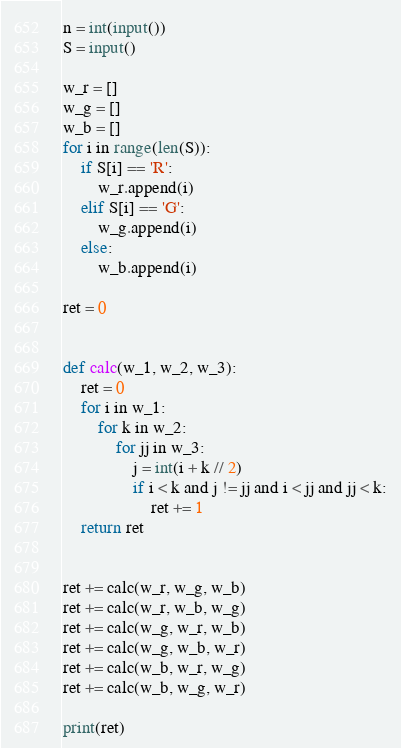Convert code to text. <code><loc_0><loc_0><loc_500><loc_500><_Python_>n = int(input())
S = input()

w_r = []
w_g = []
w_b = []
for i in range(len(S)):
    if S[i] == 'R':
        w_r.append(i)
    elif S[i] == 'G':
        w_g.append(i)
    else:
        w_b.append(i)

ret = 0


def calc(w_1, w_2, w_3):
    ret = 0
    for i in w_1:
        for k in w_2:
            for jj in w_3:
                j = int(i + k // 2)
                if i < k and j != jj and i < jj and jj < k:
                    ret += 1
    return ret


ret += calc(w_r, w_g, w_b)
ret += calc(w_r, w_b, w_g)
ret += calc(w_g, w_r, w_b)
ret += calc(w_g, w_b, w_r)
ret += calc(w_b, w_r, w_g)
ret += calc(w_b, w_g, w_r)

print(ret)
</code> 